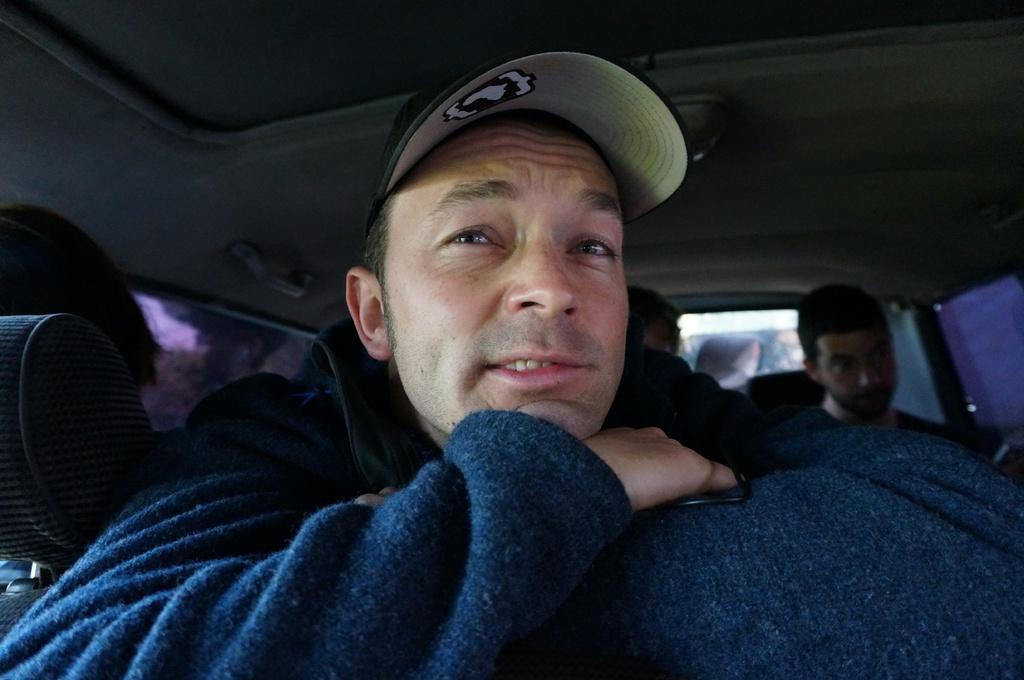Where was the image taken? The image was taken inside a car. What can be seen inside the car? There are persons sitting inside the car. Can you describe the clothing of one of the persons? A man is wearing a jacket and a cap. What type of cannon is visible in the image? There is no cannon present in the image; it was taken inside a car. Can you tell me when the birth of the person sitting in the car occurred? The provided facts do not give any information about the birth of the person sitting in the car. 